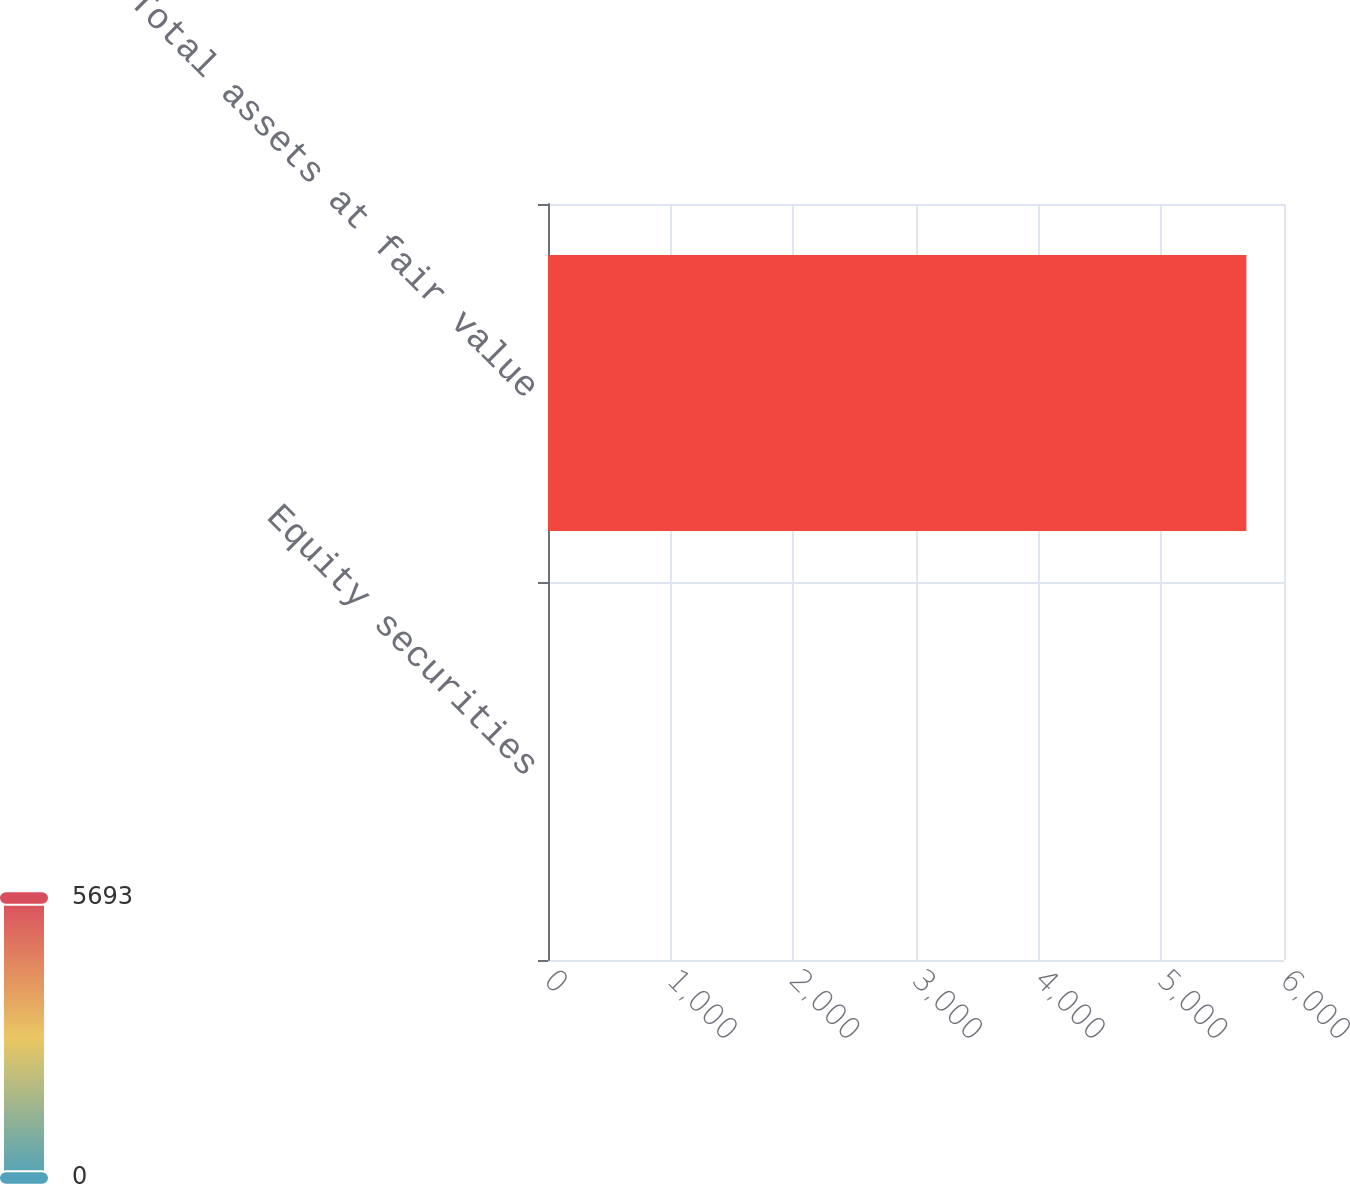Convert chart to OTSL. <chart><loc_0><loc_0><loc_500><loc_500><bar_chart><fcel>Equity securities<fcel>Total assets at fair value<nl><fcel>0.1<fcel>5693.3<nl></chart> 